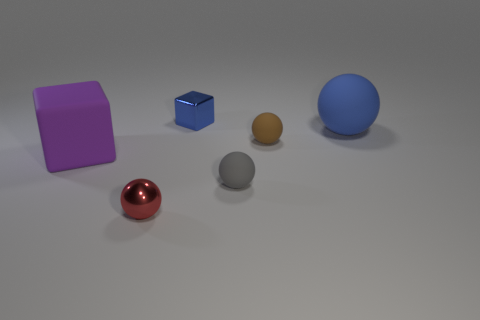Add 3 large cyan shiny balls. How many objects exist? 9 Subtract all spheres. How many objects are left? 2 Add 3 big cyan things. How many big cyan things exist? 3 Subtract 0 yellow cylinders. How many objects are left? 6 Subtract all large matte balls. Subtract all tiny rubber things. How many objects are left? 3 Add 1 blue things. How many blue things are left? 3 